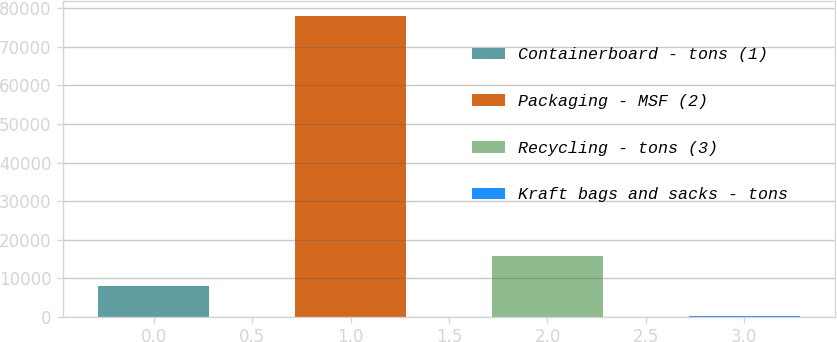Convert chart. <chart><loc_0><loc_0><loc_500><loc_500><bar_chart><fcel>Containerboard - tons (1)<fcel>Packaging - MSF (2)<fcel>Recycling - tons (3)<fcel>Kraft bags and sacks - tons<nl><fcel>7888.1<fcel>78089<fcel>15688.2<fcel>88<nl></chart> 